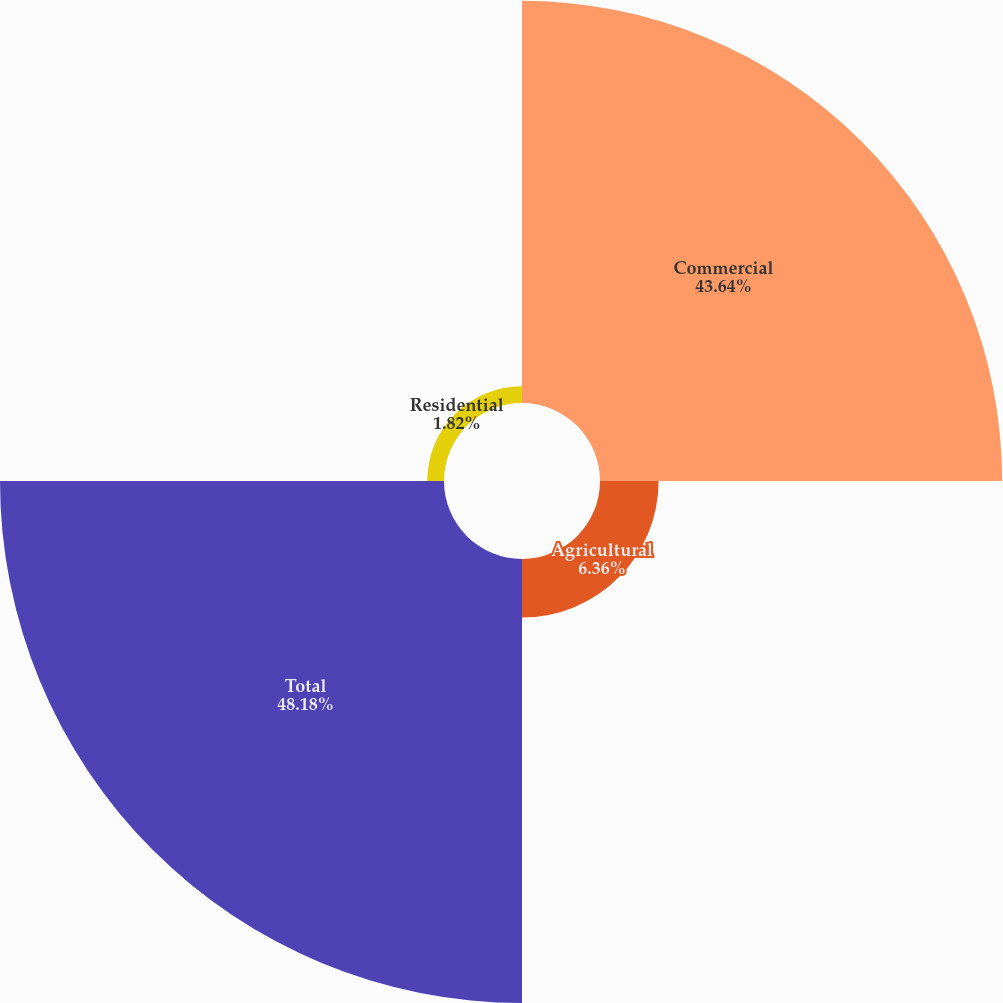<chart> <loc_0><loc_0><loc_500><loc_500><pie_chart><fcel>Commercial<fcel>Agricultural<fcel>Total<fcel>Residential<nl><fcel>43.64%<fcel>6.36%<fcel>48.18%<fcel>1.82%<nl></chart> 